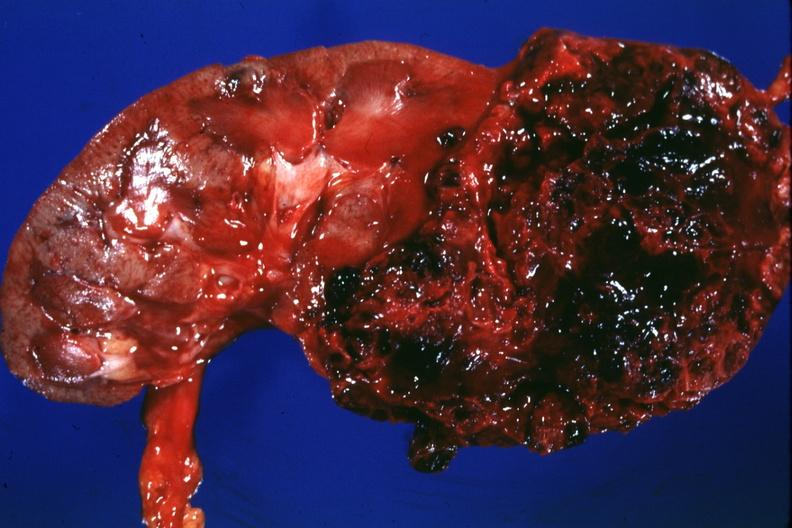what is present?
Answer the question using a single word or phrase. Renal cell carcinoma 